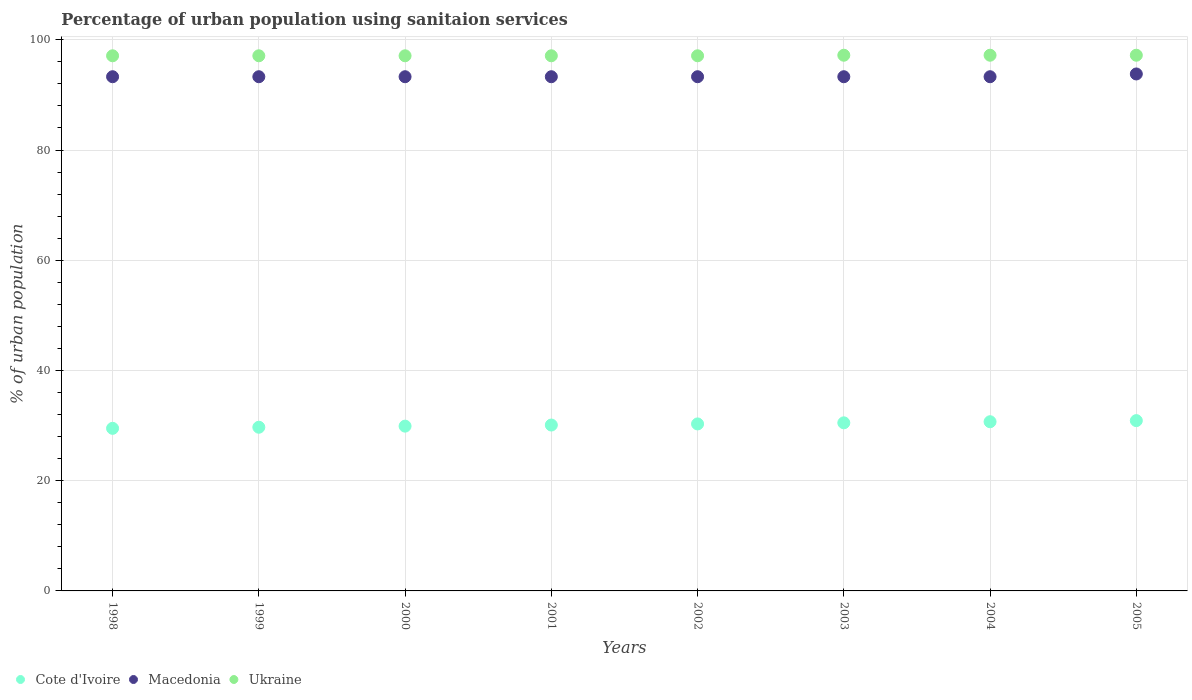How many different coloured dotlines are there?
Give a very brief answer. 3. What is the percentage of urban population using sanitaion services in Cote d'Ivoire in 2004?
Your answer should be compact. 30.7. Across all years, what is the maximum percentage of urban population using sanitaion services in Cote d'Ivoire?
Offer a terse response. 30.9. Across all years, what is the minimum percentage of urban population using sanitaion services in Macedonia?
Your answer should be very brief. 93.3. In which year was the percentage of urban population using sanitaion services in Cote d'Ivoire maximum?
Offer a terse response. 2005. What is the total percentage of urban population using sanitaion services in Macedonia in the graph?
Give a very brief answer. 746.9. What is the difference between the percentage of urban population using sanitaion services in Macedonia in 1999 and the percentage of urban population using sanitaion services in Cote d'Ivoire in 2005?
Offer a very short reply. 62.4. What is the average percentage of urban population using sanitaion services in Ukraine per year?
Your answer should be compact. 97.14. In the year 2003, what is the difference between the percentage of urban population using sanitaion services in Cote d'Ivoire and percentage of urban population using sanitaion services in Ukraine?
Ensure brevity in your answer.  -66.7. In how many years, is the percentage of urban population using sanitaion services in Cote d'Ivoire greater than 88 %?
Make the answer very short. 0. What is the ratio of the percentage of urban population using sanitaion services in Macedonia in 1998 to that in 2001?
Offer a terse response. 1. Is the percentage of urban population using sanitaion services in Cote d'Ivoire in 1999 less than that in 2004?
Make the answer very short. Yes. Is the difference between the percentage of urban population using sanitaion services in Cote d'Ivoire in 2000 and 2004 greater than the difference between the percentage of urban population using sanitaion services in Ukraine in 2000 and 2004?
Your response must be concise. No. What is the difference between the highest and the second highest percentage of urban population using sanitaion services in Cote d'Ivoire?
Ensure brevity in your answer.  0.2. What is the difference between the highest and the lowest percentage of urban population using sanitaion services in Cote d'Ivoire?
Your answer should be compact. 1.4. In how many years, is the percentage of urban population using sanitaion services in Cote d'Ivoire greater than the average percentage of urban population using sanitaion services in Cote d'Ivoire taken over all years?
Offer a very short reply. 4. Is it the case that in every year, the sum of the percentage of urban population using sanitaion services in Ukraine and percentage of urban population using sanitaion services in Cote d'Ivoire  is greater than the percentage of urban population using sanitaion services in Macedonia?
Keep it short and to the point. Yes. Does the percentage of urban population using sanitaion services in Cote d'Ivoire monotonically increase over the years?
Keep it short and to the point. Yes. Is the percentage of urban population using sanitaion services in Cote d'Ivoire strictly less than the percentage of urban population using sanitaion services in Ukraine over the years?
Keep it short and to the point. Yes. How many years are there in the graph?
Your answer should be compact. 8. What is the difference between two consecutive major ticks on the Y-axis?
Offer a terse response. 20. Does the graph contain any zero values?
Offer a terse response. No. Does the graph contain grids?
Offer a terse response. Yes. What is the title of the graph?
Offer a terse response. Percentage of urban population using sanitaion services. What is the label or title of the Y-axis?
Make the answer very short. % of urban population. What is the % of urban population of Cote d'Ivoire in 1998?
Your response must be concise. 29.5. What is the % of urban population in Macedonia in 1998?
Ensure brevity in your answer.  93.3. What is the % of urban population of Ukraine in 1998?
Your answer should be compact. 97.1. What is the % of urban population of Cote d'Ivoire in 1999?
Keep it short and to the point. 29.7. What is the % of urban population in Macedonia in 1999?
Offer a terse response. 93.3. What is the % of urban population of Ukraine in 1999?
Ensure brevity in your answer.  97.1. What is the % of urban population in Cote d'Ivoire in 2000?
Keep it short and to the point. 29.9. What is the % of urban population in Macedonia in 2000?
Ensure brevity in your answer.  93.3. What is the % of urban population of Ukraine in 2000?
Keep it short and to the point. 97.1. What is the % of urban population of Cote d'Ivoire in 2001?
Offer a very short reply. 30.1. What is the % of urban population in Macedonia in 2001?
Offer a terse response. 93.3. What is the % of urban population of Ukraine in 2001?
Offer a terse response. 97.1. What is the % of urban population of Cote d'Ivoire in 2002?
Your response must be concise. 30.3. What is the % of urban population in Macedonia in 2002?
Ensure brevity in your answer.  93.3. What is the % of urban population in Ukraine in 2002?
Your answer should be very brief. 97.1. What is the % of urban population of Cote d'Ivoire in 2003?
Give a very brief answer. 30.5. What is the % of urban population of Macedonia in 2003?
Provide a short and direct response. 93.3. What is the % of urban population of Ukraine in 2003?
Your response must be concise. 97.2. What is the % of urban population of Cote d'Ivoire in 2004?
Make the answer very short. 30.7. What is the % of urban population of Macedonia in 2004?
Offer a very short reply. 93.3. What is the % of urban population in Ukraine in 2004?
Your answer should be very brief. 97.2. What is the % of urban population in Cote d'Ivoire in 2005?
Provide a succinct answer. 30.9. What is the % of urban population in Macedonia in 2005?
Offer a very short reply. 93.8. What is the % of urban population in Ukraine in 2005?
Give a very brief answer. 97.2. Across all years, what is the maximum % of urban population in Cote d'Ivoire?
Your answer should be compact. 30.9. Across all years, what is the maximum % of urban population of Macedonia?
Your answer should be compact. 93.8. Across all years, what is the maximum % of urban population of Ukraine?
Your answer should be very brief. 97.2. Across all years, what is the minimum % of urban population of Cote d'Ivoire?
Your answer should be very brief. 29.5. Across all years, what is the minimum % of urban population in Macedonia?
Your answer should be compact. 93.3. Across all years, what is the minimum % of urban population of Ukraine?
Ensure brevity in your answer.  97.1. What is the total % of urban population of Cote d'Ivoire in the graph?
Keep it short and to the point. 241.6. What is the total % of urban population of Macedonia in the graph?
Keep it short and to the point. 746.9. What is the total % of urban population in Ukraine in the graph?
Offer a very short reply. 777.1. What is the difference between the % of urban population of Ukraine in 1998 and that in 1999?
Your answer should be compact. 0. What is the difference between the % of urban population of Macedonia in 1998 and that in 2000?
Provide a succinct answer. 0. What is the difference between the % of urban population in Ukraine in 1998 and that in 2000?
Ensure brevity in your answer.  0. What is the difference between the % of urban population in Cote d'Ivoire in 1998 and that in 2001?
Give a very brief answer. -0.6. What is the difference between the % of urban population in Macedonia in 1998 and that in 2001?
Offer a very short reply. 0. What is the difference between the % of urban population in Macedonia in 1998 and that in 2002?
Provide a succinct answer. 0. What is the difference between the % of urban population of Ukraine in 1998 and that in 2002?
Offer a terse response. 0. What is the difference between the % of urban population in Cote d'Ivoire in 1998 and that in 2003?
Ensure brevity in your answer.  -1. What is the difference between the % of urban population in Macedonia in 1998 and that in 2004?
Your answer should be very brief. 0. What is the difference between the % of urban population in Cote d'Ivoire in 1998 and that in 2005?
Provide a succinct answer. -1.4. What is the difference between the % of urban population of Ukraine in 1998 and that in 2005?
Ensure brevity in your answer.  -0.1. What is the difference between the % of urban population in Cote d'Ivoire in 1999 and that in 2000?
Keep it short and to the point. -0.2. What is the difference between the % of urban population of Macedonia in 1999 and that in 2000?
Keep it short and to the point. 0. What is the difference between the % of urban population of Cote d'Ivoire in 1999 and that in 2001?
Provide a succinct answer. -0.4. What is the difference between the % of urban population of Macedonia in 1999 and that in 2001?
Your response must be concise. 0. What is the difference between the % of urban population of Macedonia in 1999 and that in 2002?
Provide a succinct answer. 0. What is the difference between the % of urban population of Macedonia in 1999 and that in 2003?
Your response must be concise. 0. What is the difference between the % of urban population in Ukraine in 1999 and that in 2003?
Offer a terse response. -0.1. What is the difference between the % of urban population of Macedonia in 1999 and that in 2004?
Give a very brief answer. 0. What is the difference between the % of urban population in Ukraine in 1999 and that in 2004?
Your answer should be very brief. -0.1. What is the difference between the % of urban population of Cote d'Ivoire in 1999 and that in 2005?
Give a very brief answer. -1.2. What is the difference between the % of urban population in Cote d'Ivoire in 2000 and that in 2001?
Provide a short and direct response. -0.2. What is the difference between the % of urban population in Ukraine in 2000 and that in 2001?
Provide a succinct answer. 0. What is the difference between the % of urban population in Macedonia in 2000 and that in 2002?
Your answer should be very brief. 0. What is the difference between the % of urban population in Cote d'Ivoire in 2000 and that in 2003?
Provide a short and direct response. -0.6. What is the difference between the % of urban population in Macedonia in 2000 and that in 2003?
Make the answer very short. 0. What is the difference between the % of urban population of Cote d'Ivoire in 2000 and that in 2004?
Provide a succinct answer. -0.8. What is the difference between the % of urban population in Macedonia in 2000 and that in 2004?
Ensure brevity in your answer.  0. What is the difference between the % of urban population in Ukraine in 2000 and that in 2004?
Ensure brevity in your answer.  -0.1. What is the difference between the % of urban population of Macedonia in 2000 and that in 2005?
Your answer should be very brief. -0.5. What is the difference between the % of urban population of Ukraine in 2000 and that in 2005?
Your answer should be very brief. -0.1. What is the difference between the % of urban population in Macedonia in 2001 and that in 2002?
Offer a very short reply. 0. What is the difference between the % of urban population of Ukraine in 2001 and that in 2002?
Ensure brevity in your answer.  0. What is the difference between the % of urban population of Macedonia in 2001 and that in 2003?
Your answer should be compact. 0. What is the difference between the % of urban population in Ukraine in 2001 and that in 2003?
Provide a short and direct response. -0.1. What is the difference between the % of urban population of Cote d'Ivoire in 2001 and that in 2004?
Provide a short and direct response. -0.6. What is the difference between the % of urban population of Macedonia in 2001 and that in 2004?
Your answer should be compact. 0. What is the difference between the % of urban population of Ukraine in 2001 and that in 2004?
Your answer should be compact. -0.1. What is the difference between the % of urban population in Cote d'Ivoire in 2001 and that in 2005?
Provide a short and direct response. -0.8. What is the difference between the % of urban population in Macedonia in 2001 and that in 2005?
Make the answer very short. -0.5. What is the difference between the % of urban population in Cote d'Ivoire in 2002 and that in 2003?
Offer a very short reply. -0.2. What is the difference between the % of urban population of Macedonia in 2002 and that in 2003?
Your answer should be compact. 0. What is the difference between the % of urban population of Macedonia in 2002 and that in 2004?
Offer a very short reply. 0. What is the difference between the % of urban population in Cote d'Ivoire in 2002 and that in 2005?
Your response must be concise. -0.6. What is the difference between the % of urban population of Ukraine in 2002 and that in 2005?
Offer a terse response. -0.1. What is the difference between the % of urban population in Ukraine in 2003 and that in 2004?
Ensure brevity in your answer.  0. What is the difference between the % of urban population of Ukraine in 2004 and that in 2005?
Offer a very short reply. 0. What is the difference between the % of urban population in Cote d'Ivoire in 1998 and the % of urban population in Macedonia in 1999?
Offer a very short reply. -63.8. What is the difference between the % of urban population in Cote d'Ivoire in 1998 and the % of urban population in Ukraine in 1999?
Provide a succinct answer. -67.6. What is the difference between the % of urban population of Cote d'Ivoire in 1998 and the % of urban population of Macedonia in 2000?
Provide a succinct answer. -63.8. What is the difference between the % of urban population in Cote d'Ivoire in 1998 and the % of urban population in Ukraine in 2000?
Make the answer very short. -67.6. What is the difference between the % of urban population in Cote d'Ivoire in 1998 and the % of urban population in Macedonia in 2001?
Keep it short and to the point. -63.8. What is the difference between the % of urban population in Cote d'Ivoire in 1998 and the % of urban population in Ukraine in 2001?
Offer a very short reply. -67.6. What is the difference between the % of urban population of Macedonia in 1998 and the % of urban population of Ukraine in 2001?
Give a very brief answer. -3.8. What is the difference between the % of urban population in Cote d'Ivoire in 1998 and the % of urban population in Macedonia in 2002?
Make the answer very short. -63.8. What is the difference between the % of urban population of Cote d'Ivoire in 1998 and the % of urban population of Ukraine in 2002?
Your response must be concise. -67.6. What is the difference between the % of urban population in Cote d'Ivoire in 1998 and the % of urban population in Macedonia in 2003?
Provide a succinct answer. -63.8. What is the difference between the % of urban population of Cote d'Ivoire in 1998 and the % of urban population of Ukraine in 2003?
Your response must be concise. -67.7. What is the difference between the % of urban population in Macedonia in 1998 and the % of urban population in Ukraine in 2003?
Keep it short and to the point. -3.9. What is the difference between the % of urban population of Cote d'Ivoire in 1998 and the % of urban population of Macedonia in 2004?
Ensure brevity in your answer.  -63.8. What is the difference between the % of urban population of Cote d'Ivoire in 1998 and the % of urban population of Ukraine in 2004?
Your answer should be compact. -67.7. What is the difference between the % of urban population of Cote d'Ivoire in 1998 and the % of urban population of Macedonia in 2005?
Provide a succinct answer. -64.3. What is the difference between the % of urban population in Cote d'Ivoire in 1998 and the % of urban population in Ukraine in 2005?
Your answer should be very brief. -67.7. What is the difference between the % of urban population of Macedonia in 1998 and the % of urban population of Ukraine in 2005?
Provide a succinct answer. -3.9. What is the difference between the % of urban population of Cote d'Ivoire in 1999 and the % of urban population of Macedonia in 2000?
Provide a short and direct response. -63.6. What is the difference between the % of urban population of Cote d'Ivoire in 1999 and the % of urban population of Ukraine in 2000?
Your answer should be very brief. -67.4. What is the difference between the % of urban population of Macedonia in 1999 and the % of urban population of Ukraine in 2000?
Ensure brevity in your answer.  -3.8. What is the difference between the % of urban population of Cote d'Ivoire in 1999 and the % of urban population of Macedonia in 2001?
Make the answer very short. -63.6. What is the difference between the % of urban population in Cote d'Ivoire in 1999 and the % of urban population in Ukraine in 2001?
Your response must be concise. -67.4. What is the difference between the % of urban population in Cote d'Ivoire in 1999 and the % of urban population in Macedonia in 2002?
Your answer should be very brief. -63.6. What is the difference between the % of urban population of Cote d'Ivoire in 1999 and the % of urban population of Ukraine in 2002?
Give a very brief answer. -67.4. What is the difference between the % of urban population of Cote d'Ivoire in 1999 and the % of urban population of Macedonia in 2003?
Your answer should be very brief. -63.6. What is the difference between the % of urban population in Cote d'Ivoire in 1999 and the % of urban population in Ukraine in 2003?
Your answer should be compact. -67.5. What is the difference between the % of urban population of Macedonia in 1999 and the % of urban population of Ukraine in 2003?
Provide a succinct answer. -3.9. What is the difference between the % of urban population in Cote d'Ivoire in 1999 and the % of urban population in Macedonia in 2004?
Your answer should be compact. -63.6. What is the difference between the % of urban population in Cote d'Ivoire in 1999 and the % of urban population in Ukraine in 2004?
Make the answer very short. -67.5. What is the difference between the % of urban population in Macedonia in 1999 and the % of urban population in Ukraine in 2004?
Offer a very short reply. -3.9. What is the difference between the % of urban population in Cote d'Ivoire in 1999 and the % of urban population in Macedonia in 2005?
Make the answer very short. -64.1. What is the difference between the % of urban population in Cote d'Ivoire in 1999 and the % of urban population in Ukraine in 2005?
Ensure brevity in your answer.  -67.5. What is the difference between the % of urban population of Macedonia in 1999 and the % of urban population of Ukraine in 2005?
Your answer should be very brief. -3.9. What is the difference between the % of urban population in Cote d'Ivoire in 2000 and the % of urban population in Macedonia in 2001?
Keep it short and to the point. -63.4. What is the difference between the % of urban population in Cote d'Ivoire in 2000 and the % of urban population in Ukraine in 2001?
Your answer should be compact. -67.2. What is the difference between the % of urban population in Macedonia in 2000 and the % of urban population in Ukraine in 2001?
Your response must be concise. -3.8. What is the difference between the % of urban population in Cote d'Ivoire in 2000 and the % of urban population in Macedonia in 2002?
Your answer should be very brief. -63.4. What is the difference between the % of urban population in Cote d'Ivoire in 2000 and the % of urban population in Ukraine in 2002?
Give a very brief answer. -67.2. What is the difference between the % of urban population in Cote d'Ivoire in 2000 and the % of urban population in Macedonia in 2003?
Offer a terse response. -63.4. What is the difference between the % of urban population in Cote d'Ivoire in 2000 and the % of urban population in Ukraine in 2003?
Offer a very short reply. -67.3. What is the difference between the % of urban population in Cote d'Ivoire in 2000 and the % of urban population in Macedonia in 2004?
Your response must be concise. -63.4. What is the difference between the % of urban population in Cote d'Ivoire in 2000 and the % of urban population in Ukraine in 2004?
Provide a succinct answer. -67.3. What is the difference between the % of urban population of Macedonia in 2000 and the % of urban population of Ukraine in 2004?
Give a very brief answer. -3.9. What is the difference between the % of urban population in Cote d'Ivoire in 2000 and the % of urban population in Macedonia in 2005?
Keep it short and to the point. -63.9. What is the difference between the % of urban population in Cote d'Ivoire in 2000 and the % of urban population in Ukraine in 2005?
Provide a short and direct response. -67.3. What is the difference between the % of urban population in Cote d'Ivoire in 2001 and the % of urban population in Macedonia in 2002?
Your response must be concise. -63.2. What is the difference between the % of urban population in Cote d'Ivoire in 2001 and the % of urban population in Ukraine in 2002?
Provide a succinct answer. -67. What is the difference between the % of urban population of Cote d'Ivoire in 2001 and the % of urban population of Macedonia in 2003?
Make the answer very short. -63.2. What is the difference between the % of urban population of Cote d'Ivoire in 2001 and the % of urban population of Ukraine in 2003?
Offer a very short reply. -67.1. What is the difference between the % of urban population of Macedonia in 2001 and the % of urban population of Ukraine in 2003?
Offer a very short reply. -3.9. What is the difference between the % of urban population in Cote d'Ivoire in 2001 and the % of urban population in Macedonia in 2004?
Provide a short and direct response. -63.2. What is the difference between the % of urban population of Cote d'Ivoire in 2001 and the % of urban population of Ukraine in 2004?
Keep it short and to the point. -67.1. What is the difference between the % of urban population in Cote d'Ivoire in 2001 and the % of urban population in Macedonia in 2005?
Your response must be concise. -63.7. What is the difference between the % of urban population in Cote d'Ivoire in 2001 and the % of urban population in Ukraine in 2005?
Keep it short and to the point. -67.1. What is the difference between the % of urban population of Macedonia in 2001 and the % of urban population of Ukraine in 2005?
Give a very brief answer. -3.9. What is the difference between the % of urban population of Cote d'Ivoire in 2002 and the % of urban population of Macedonia in 2003?
Offer a terse response. -63. What is the difference between the % of urban population in Cote d'Ivoire in 2002 and the % of urban population in Ukraine in 2003?
Provide a succinct answer. -66.9. What is the difference between the % of urban population in Macedonia in 2002 and the % of urban population in Ukraine in 2003?
Your answer should be compact. -3.9. What is the difference between the % of urban population of Cote d'Ivoire in 2002 and the % of urban population of Macedonia in 2004?
Your response must be concise. -63. What is the difference between the % of urban population of Cote d'Ivoire in 2002 and the % of urban population of Ukraine in 2004?
Keep it short and to the point. -66.9. What is the difference between the % of urban population in Macedonia in 2002 and the % of urban population in Ukraine in 2004?
Your answer should be compact. -3.9. What is the difference between the % of urban population of Cote d'Ivoire in 2002 and the % of urban population of Macedonia in 2005?
Ensure brevity in your answer.  -63.5. What is the difference between the % of urban population in Cote d'Ivoire in 2002 and the % of urban population in Ukraine in 2005?
Your answer should be very brief. -66.9. What is the difference between the % of urban population of Macedonia in 2002 and the % of urban population of Ukraine in 2005?
Ensure brevity in your answer.  -3.9. What is the difference between the % of urban population in Cote d'Ivoire in 2003 and the % of urban population in Macedonia in 2004?
Keep it short and to the point. -62.8. What is the difference between the % of urban population in Cote d'Ivoire in 2003 and the % of urban population in Ukraine in 2004?
Ensure brevity in your answer.  -66.7. What is the difference between the % of urban population of Cote d'Ivoire in 2003 and the % of urban population of Macedonia in 2005?
Provide a succinct answer. -63.3. What is the difference between the % of urban population of Cote d'Ivoire in 2003 and the % of urban population of Ukraine in 2005?
Keep it short and to the point. -66.7. What is the difference between the % of urban population in Macedonia in 2003 and the % of urban population in Ukraine in 2005?
Give a very brief answer. -3.9. What is the difference between the % of urban population of Cote d'Ivoire in 2004 and the % of urban population of Macedonia in 2005?
Offer a very short reply. -63.1. What is the difference between the % of urban population in Cote d'Ivoire in 2004 and the % of urban population in Ukraine in 2005?
Make the answer very short. -66.5. What is the difference between the % of urban population in Macedonia in 2004 and the % of urban population in Ukraine in 2005?
Offer a very short reply. -3.9. What is the average % of urban population of Cote d'Ivoire per year?
Offer a very short reply. 30.2. What is the average % of urban population of Macedonia per year?
Give a very brief answer. 93.36. What is the average % of urban population of Ukraine per year?
Provide a short and direct response. 97.14. In the year 1998, what is the difference between the % of urban population in Cote d'Ivoire and % of urban population in Macedonia?
Offer a very short reply. -63.8. In the year 1998, what is the difference between the % of urban population in Cote d'Ivoire and % of urban population in Ukraine?
Your answer should be compact. -67.6. In the year 1999, what is the difference between the % of urban population of Cote d'Ivoire and % of urban population of Macedonia?
Keep it short and to the point. -63.6. In the year 1999, what is the difference between the % of urban population in Cote d'Ivoire and % of urban population in Ukraine?
Give a very brief answer. -67.4. In the year 1999, what is the difference between the % of urban population of Macedonia and % of urban population of Ukraine?
Provide a succinct answer. -3.8. In the year 2000, what is the difference between the % of urban population in Cote d'Ivoire and % of urban population in Macedonia?
Provide a succinct answer. -63.4. In the year 2000, what is the difference between the % of urban population of Cote d'Ivoire and % of urban population of Ukraine?
Your answer should be very brief. -67.2. In the year 2000, what is the difference between the % of urban population in Macedonia and % of urban population in Ukraine?
Your answer should be very brief. -3.8. In the year 2001, what is the difference between the % of urban population in Cote d'Ivoire and % of urban population in Macedonia?
Provide a succinct answer. -63.2. In the year 2001, what is the difference between the % of urban population of Cote d'Ivoire and % of urban population of Ukraine?
Give a very brief answer. -67. In the year 2001, what is the difference between the % of urban population of Macedonia and % of urban population of Ukraine?
Your response must be concise. -3.8. In the year 2002, what is the difference between the % of urban population of Cote d'Ivoire and % of urban population of Macedonia?
Provide a succinct answer. -63. In the year 2002, what is the difference between the % of urban population of Cote d'Ivoire and % of urban population of Ukraine?
Provide a succinct answer. -66.8. In the year 2003, what is the difference between the % of urban population in Cote d'Ivoire and % of urban population in Macedonia?
Your response must be concise. -62.8. In the year 2003, what is the difference between the % of urban population in Cote d'Ivoire and % of urban population in Ukraine?
Provide a short and direct response. -66.7. In the year 2003, what is the difference between the % of urban population in Macedonia and % of urban population in Ukraine?
Keep it short and to the point. -3.9. In the year 2004, what is the difference between the % of urban population in Cote d'Ivoire and % of urban population in Macedonia?
Provide a short and direct response. -62.6. In the year 2004, what is the difference between the % of urban population of Cote d'Ivoire and % of urban population of Ukraine?
Offer a very short reply. -66.5. In the year 2004, what is the difference between the % of urban population in Macedonia and % of urban population in Ukraine?
Give a very brief answer. -3.9. In the year 2005, what is the difference between the % of urban population in Cote d'Ivoire and % of urban population in Macedonia?
Give a very brief answer. -62.9. In the year 2005, what is the difference between the % of urban population in Cote d'Ivoire and % of urban population in Ukraine?
Offer a very short reply. -66.3. What is the ratio of the % of urban population of Cote d'Ivoire in 1998 to that in 1999?
Provide a short and direct response. 0.99. What is the ratio of the % of urban population in Ukraine in 1998 to that in 1999?
Provide a succinct answer. 1. What is the ratio of the % of urban population of Cote d'Ivoire in 1998 to that in 2000?
Your answer should be very brief. 0.99. What is the ratio of the % of urban population in Macedonia in 1998 to that in 2000?
Your answer should be very brief. 1. What is the ratio of the % of urban population in Ukraine in 1998 to that in 2000?
Give a very brief answer. 1. What is the ratio of the % of urban population of Cote d'Ivoire in 1998 to that in 2001?
Provide a succinct answer. 0.98. What is the ratio of the % of urban population of Ukraine in 1998 to that in 2001?
Offer a terse response. 1. What is the ratio of the % of urban population of Cote d'Ivoire in 1998 to that in 2002?
Your response must be concise. 0.97. What is the ratio of the % of urban population in Macedonia in 1998 to that in 2002?
Keep it short and to the point. 1. What is the ratio of the % of urban population of Cote d'Ivoire in 1998 to that in 2003?
Your answer should be compact. 0.97. What is the ratio of the % of urban population in Ukraine in 1998 to that in 2003?
Provide a short and direct response. 1. What is the ratio of the % of urban population of Cote d'Ivoire in 1998 to that in 2004?
Give a very brief answer. 0.96. What is the ratio of the % of urban population of Macedonia in 1998 to that in 2004?
Provide a short and direct response. 1. What is the ratio of the % of urban population of Ukraine in 1998 to that in 2004?
Provide a succinct answer. 1. What is the ratio of the % of urban population in Cote d'Ivoire in 1998 to that in 2005?
Offer a very short reply. 0.95. What is the ratio of the % of urban population of Macedonia in 1998 to that in 2005?
Make the answer very short. 0.99. What is the ratio of the % of urban population in Ukraine in 1998 to that in 2005?
Your response must be concise. 1. What is the ratio of the % of urban population in Macedonia in 1999 to that in 2000?
Ensure brevity in your answer.  1. What is the ratio of the % of urban population in Cote d'Ivoire in 1999 to that in 2001?
Give a very brief answer. 0.99. What is the ratio of the % of urban population in Macedonia in 1999 to that in 2001?
Offer a very short reply. 1. What is the ratio of the % of urban population of Cote d'Ivoire in 1999 to that in 2002?
Your answer should be very brief. 0.98. What is the ratio of the % of urban population in Cote d'Ivoire in 1999 to that in 2003?
Offer a terse response. 0.97. What is the ratio of the % of urban population of Ukraine in 1999 to that in 2003?
Your answer should be very brief. 1. What is the ratio of the % of urban population of Cote d'Ivoire in 1999 to that in 2004?
Your response must be concise. 0.97. What is the ratio of the % of urban population of Macedonia in 1999 to that in 2004?
Your answer should be very brief. 1. What is the ratio of the % of urban population in Ukraine in 1999 to that in 2004?
Keep it short and to the point. 1. What is the ratio of the % of urban population of Cote d'Ivoire in 1999 to that in 2005?
Make the answer very short. 0.96. What is the ratio of the % of urban population of Macedonia in 1999 to that in 2005?
Your answer should be very brief. 0.99. What is the ratio of the % of urban population in Ukraine in 1999 to that in 2005?
Ensure brevity in your answer.  1. What is the ratio of the % of urban population of Cote d'Ivoire in 2000 to that in 2001?
Ensure brevity in your answer.  0.99. What is the ratio of the % of urban population in Macedonia in 2000 to that in 2001?
Provide a succinct answer. 1. What is the ratio of the % of urban population in Ukraine in 2000 to that in 2001?
Provide a succinct answer. 1. What is the ratio of the % of urban population in Macedonia in 2000 to that in 2002?
Your response must be concise. 1. What is the ratio of the % of urban population in Ukraine in 2000 to that in 2002?
Offer a very short reply. 1. What is the ratio of the % of urban population in Cote d'Ivoire in 2000 to that in 2003?
Provide a succinct answer. 0.98. What is the ratio of the % of urban population in Macedonia in 2000 to that in 2003?
Provide a succinct answer. 1. What is the ratio of the % of urban population in Ukraine in 2000 to that in 2003?
Offer a very short reply. 1. What is the ratio of the % of urban population of Cote d'Ivoire in 2000 to that in 2004?
Your response must be concise. 0.97. What is the ratio of the % of urban population of Ukraine in 2000 to that in 2004?
Keep it short and to the point. 1. What is the ratio of the % of urban population of Cote d'Ivoire in 2000 to that in 2005?
Your answer should be very brief. 0.97. What is the ratio of the % of urban population of Ukraine in 2000 to that in 2005?
Offer a very short reply. 1. What is the ratio of the % of urban population of Ukraine in 2001 to that in 2002?
Keep it short and to the point. 1. What is the ratio of the % of urban population of Cote d'Ivoire in 2001 to that in 2003?
Ensure brevity in your answer.  0.99. What is the ratio of the % of urban population of Macedonia in 2001 to that in 2003?
Your answer should be compact. 1. What is the ratio of the % of urban population in Ukraine in 2001 to that in 2003?
Your answer should be compact. 1. What is the ratio of the % of urban population of Cote d'Ivoire in 2001 to that in 2004?
Your answer should be compact. 0.98. What is the ratio of the % of urban population in Macedonia in 2001 to that in 2004?
Provide a succinct answer. 1. What is the ratio of the % of urban population in Ukraine in 2001 to that in 2004?
Offer a very short reply. 1. What is the ratio of the % of urban population of Cote d'Ivoire in 2001 to that in 2005?
Provide a short and direct response. 0.97. What is the ratio of the % of urban population of Cote d'Ivoire in 2002 to that in 2003?
Your answer should be compact. 0.99. What is the ratio of the % of urban population in Macedonia in 2002 to that in 2004?
Your answer should be compact. 1. What is the ratio of the % of urban population of Ukraine in 2002 to that in 2004?
Your answer should be very brief. 1. What is the ratio of the % of urban population of Cote d'Ivoire in 2002 to that in 2005?
Give a very brief answer. 0.98. What is the ratio of the % of urban population of Ukraine in 2002 to that in 2005?
Your answer should be compact. 1. What is the ratio of the % of urban population in Macedonia in 2003 to that in 2004?
Provide a succinct answer. 1. What is the ratio of the % of urban population of Ukraine in 2003 to that in 2004?
Your answer should be compact. 1. What is the ratio of the % of urban population of Cote d'Ivoire in 2003 to that in 2005?
Give a very brief answer. 0.99. What is the ratio of the % of urban population of Macedonia in 2003 to that in 2005?
Make the answer very short. 0.99. What is the difference between the highest and the second highest % of urban population in Macedonia?
Give a very brief answer. 0.5. What is the difference between the highest and the lowest % of urban population of Macedonia?
Keep it short and to the point. 0.5. What is the difference between the highest and the lowest % of urban population in Ukraine?
Provide a succinct answer. 0.1. 